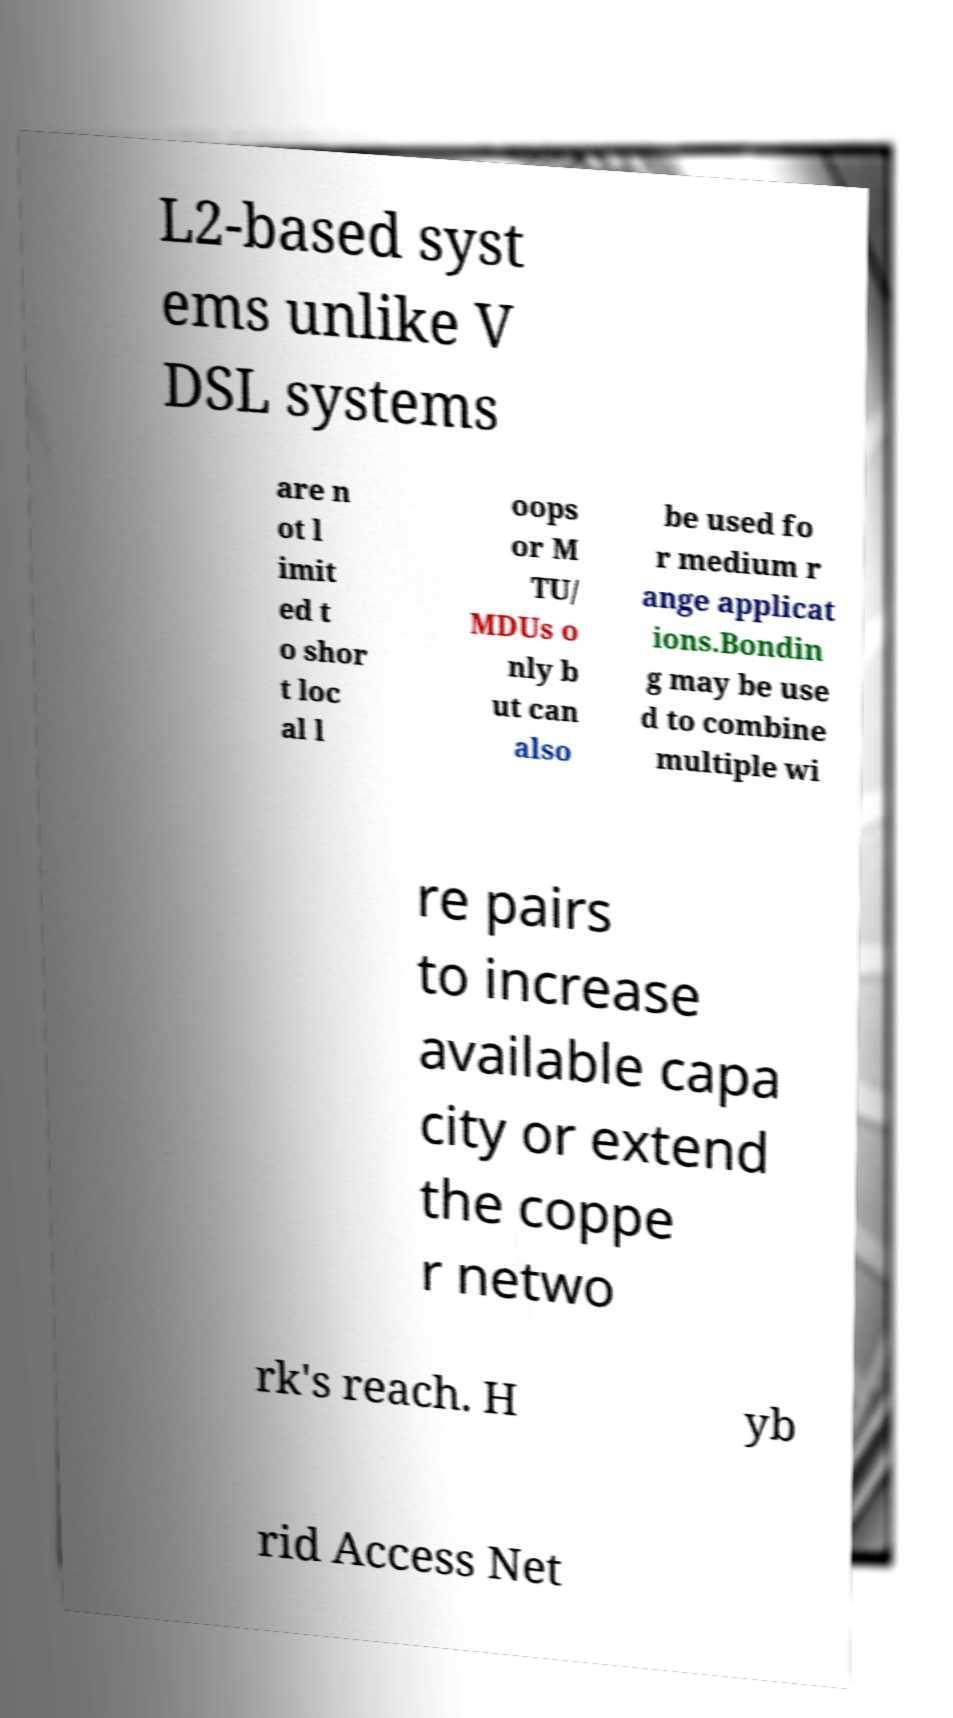Please read and relay the text visible in this image. What does it say? L2-based syst ems unlike V DSL systems are n ot l imit ed t o shor t loc al l oops or M TU/ MDUs o nly b ut can also be used fo r medium r ange applicat ions.Bondin g may be use d to combine multiple wi re pairs to increase available capa city or extend the coppe r netwo rk's reach. H yb rid Access Net 